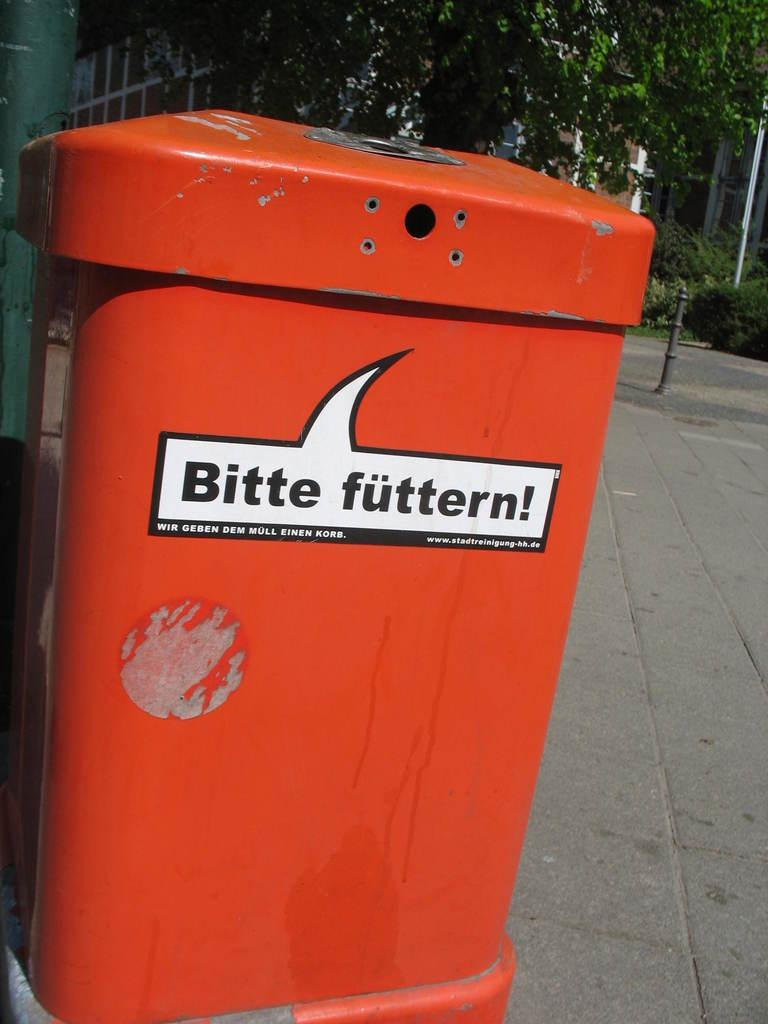<image>
Relay a brief, clear account of the picture shown. A trashcan that says Bitte futtern! on it. 